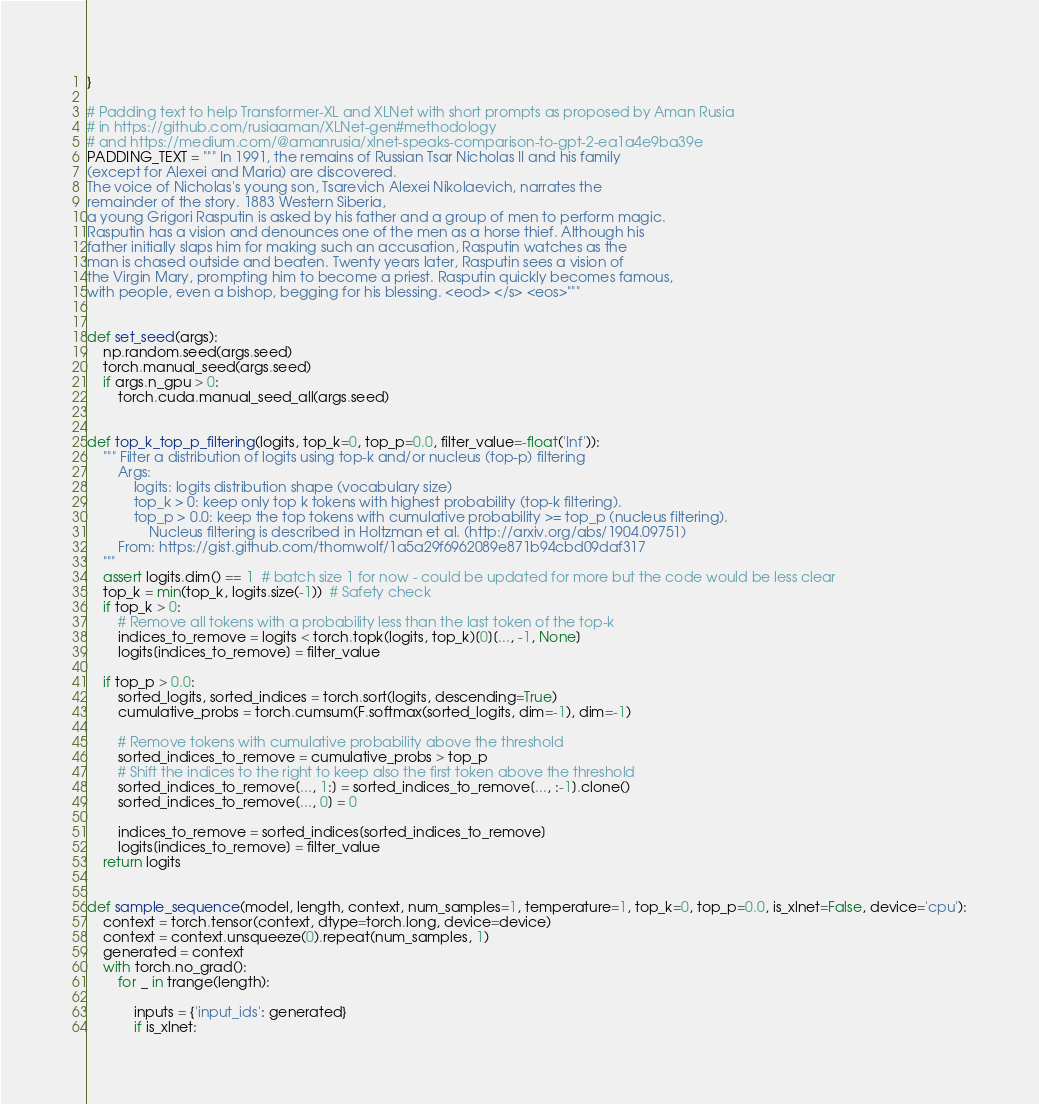<code> <loc_0><loc_0><loc_500><loc_500><_Python_>}

# Padding text to help Transformer-XL and XLNet with short prompts as proposed by Aman Rusia
# in https://github.com/rusiaaman/XLNet-gen#methodology
# and https://medium.com/@amanrusia/xlnet-speaks-comparison-to-gpt-2-ea1a4e9ba39e
PADDING_TEXT = """ In 1991, the remains of Russian Tsar Nicholas II and his family
(except for Alexei and Maria) are discovered.
The voice of Nicholas's young son, Tsarevich Alexei Nikolaevich, narrates the
remainder of the story. 1883 Western Siberia,
a young Grigori Rasputin is asked by his father and a group of men to perform magic.
Rasputin has a vision and denounces one of the men as a horse thief. Although his
father initially slaps him for making such an accusation, Rasputin watches as the
man is chased outside and beaten. Twenty years later, Rasputin sees a vision of
the Virgin Mary, prompting him to become a priest. Rasputin quickly becomes famous,
with people, even a bishop, begging for his blessing. <eod> </s> <eos>"""


def set_seed(args):
    np.random.seed(args.seed)
    torch.manual_seed(args.seed)
    if args.n_gpu > 0:
        torch.cuda.manual_seed_all(args.seed)


def top_k_top_p_filtering(logits, top_k=0, top_p=0.0, filter_value=-float('Inf')):
    """ Filter a distribution of logits using top-k and/or nucleus (top-p) filtering
        Args:
            logits: logits distribution shape (vocabulary size)
            top_k > 0: keep only top k tokens with highest probability (top-k filtering).
            top_p > 0.0: keep the top tokens with cumulative probability >= top_p (nucleus filtering).
                Nucleus filtering is described in Holtzman et al. (http://arxiv.org/abs/1904.09751)
        From: https://gist.github.com/thomwolf/1a5a29f6962089e871b94cbd09daf317
    """
    assert logits.dim() == 1  # batch size 1 for now - could be updated for more but the code would be less clear
    top_k = min(top_k, logits.size(-1))  # Safety check
    if top_k > 0:
        # Remove all tokens with a probability less than the last token of the top-k
        indices_to_remove = logits < torch.topk(logits, top_k)[0][..., -1, None]
        logits[indices_to_remove] = filter_value

    if top_p > 0.0:
        sorted_logits, sorted_indices = torch.sort(logits, descending=True)
        cumulative_probs = torch.cumsum(F.softmax(sorted_logits, dim=-1), dim=-1)

        # Remove tokens with cumulative probability above the threshold
        sorted_indices_to_remove = cumulative_probs > top_p
        # Shift the indices to the right to keep also the first token above the threshold
        sorted_indices_to_remove[..., 1:] = sorted_indices_to_remove[..., :-1].clone()
        sorted_indices_to_remove[..., 0] = 0

        indices_to_remove = sorted_indices[sorted_indices_to_remove]
        logits[indices_to_remove] = filter_value
    return logits


def sample_sequence(model, length, context, num_samples=1, temperature=1, top_k=0, top_p=0.0, is_xlnet=False, device='cpu'):
    context = torch.tensor(context, dtype=torch.long, device=device)
    context = context.unsqueeze(0).repeat(num_samples, 1)
    generated = context
    with torch.no_grad():
        for _ in trange(length):

            inputs = {'input_ids': generated}
            if is_xlnet: </code> 